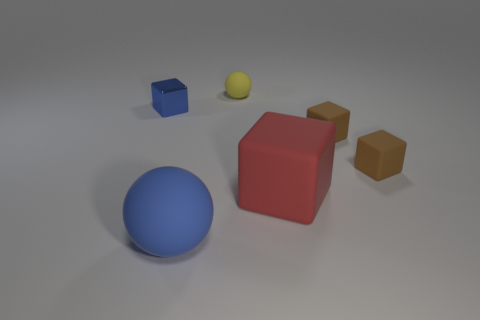There is a tiny yellow matte sphere; are there any large matte cubes in front of it?
Your response must be concise. Yes. What number of things are either small things on the right side of the big rubber ball or large cyan shiny cubes?
Your answer should be very brief. 3. What number of blue objects are either big cylinders or tiny blocks?
Keep it short and to the point. 1. What number of other things are there of the same color as the tiny metallic object?
Provide a succinct answer. 1. Is the number of blue matte things that are right of the large matte sphere less than the number of large blue rubber balls?
Your answer should be compact. Yes. There is a large rubber thing to the left of the tiny matte thing behind the block that is to the left of the yellow rubber thing; what color is it?
Offer a terse response. Blue. Is there any other thing that has the same material as the blue block?
Your answer should be very brief. No. What is the size of the metallic thing that is the same shape as the large red matte object?
Your answer should be very brief. Small. Is the number of blue rubber things that are behind the tiny blue thing less than the number of tiny brown cubes that are behind the big blue rubber sphere?
Offer a terse response. Yes. What is the shape of the small thing that is left of the big cube and in front of the yellow rubber object?
Your answer should be very brief. Cube. 